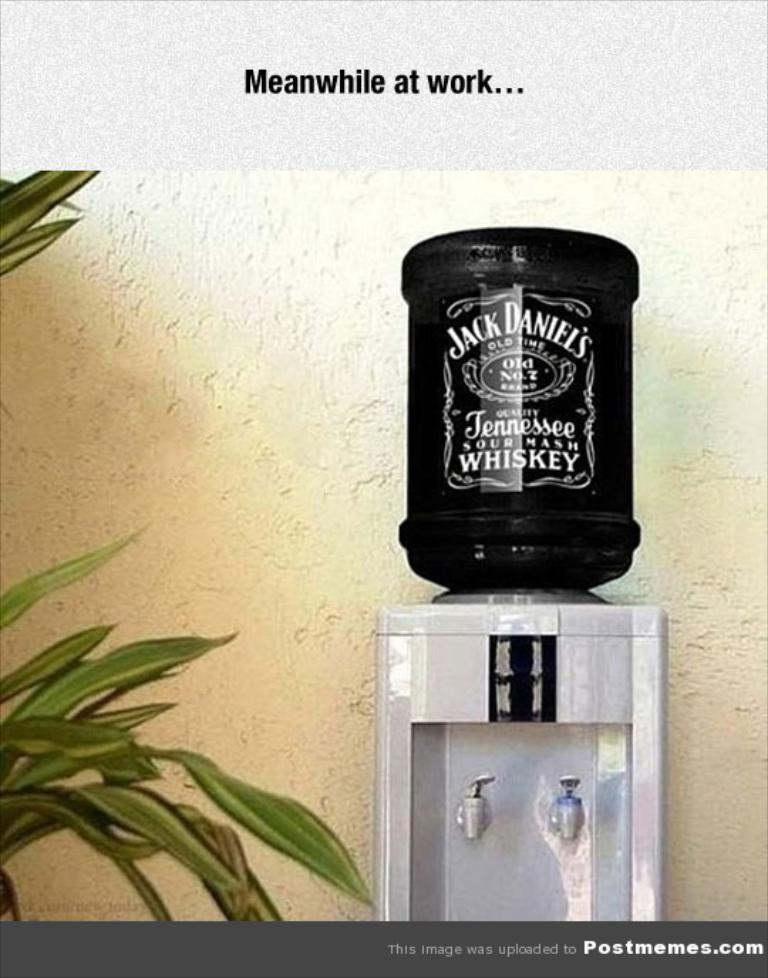What is on top of the water filter in the image? There is a bottle on the water filter in the image. What other object is near the water filter? There is a plant beside the water filter in the image. What type of suit is the person wearing in the image? There is no person present in the image, so it is not possible to determine what type of suit they might be wearing. 